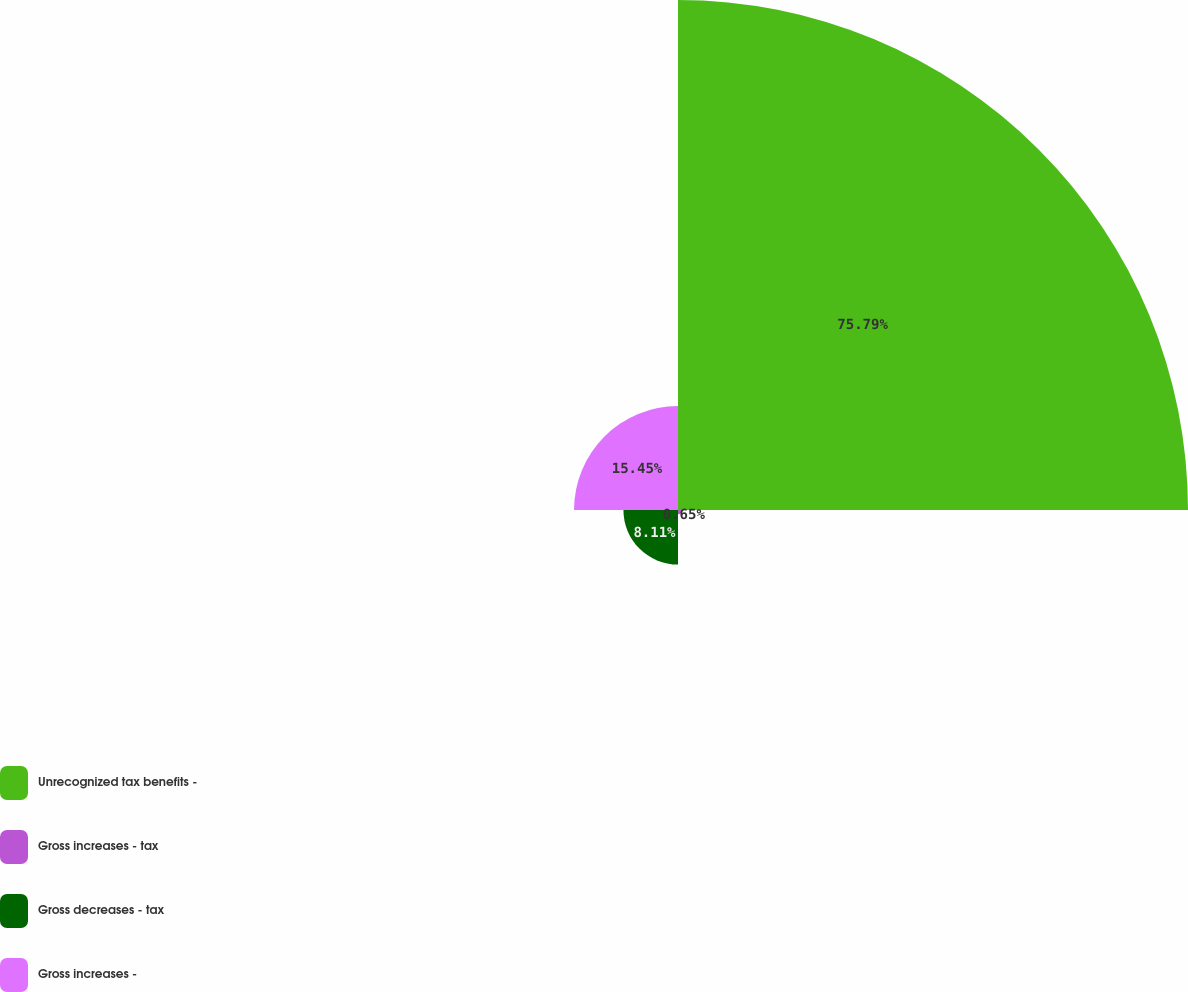Convert chart. <chart><loc_0><loc_0><loc_500><loc_500><pie_chart><fcel>Unrecognized tax benefits -<fcel>Gross increases - tax<fcel>Gross decreases - tax<fcel>Gross increases -<nl><fcel>75.79%<fcel>0.65%<fcel>8.11%<fcel>15.45%<nl></chart> 